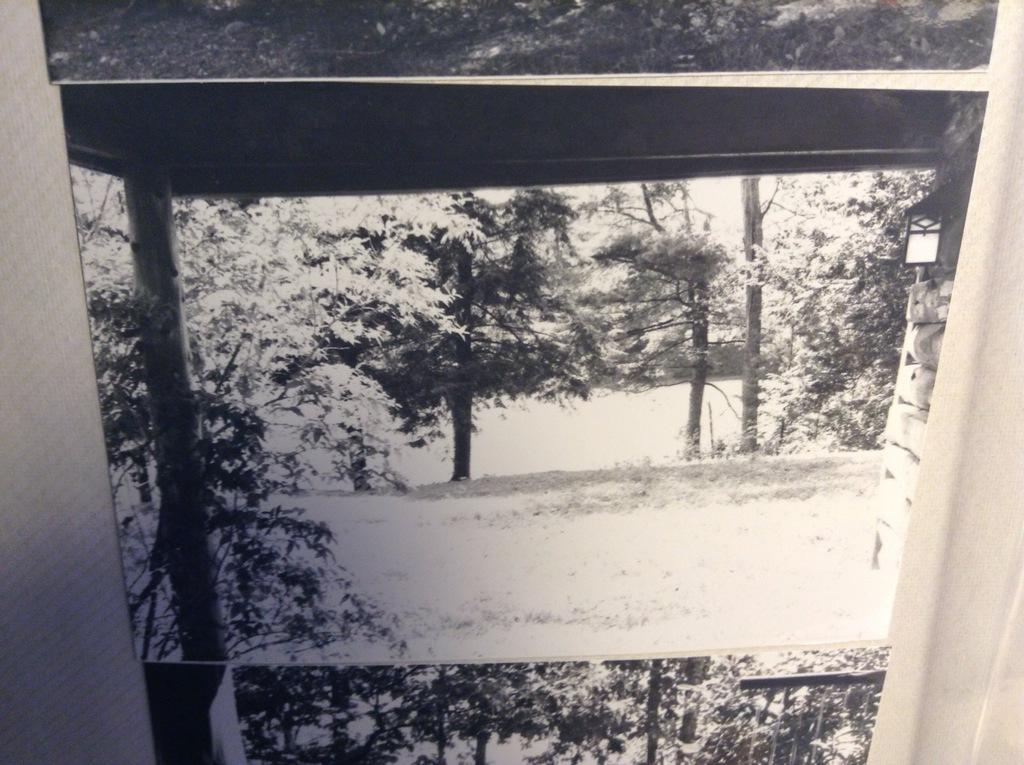What type of window treatment is visible in the image? There are curtains in the image. What type of natural scenery is present in the image? There are trees in the image. What color scheme is used in the image? The image is in black and white. What type of lamp is hanging from the tree in the image? There is no lamp present in the image; it only features curtains and trees. What type of stone is visible on the ground in the image? There is no stone visible in the image; it is in black and white and only shows curtains and trees. 